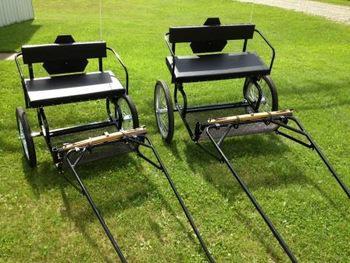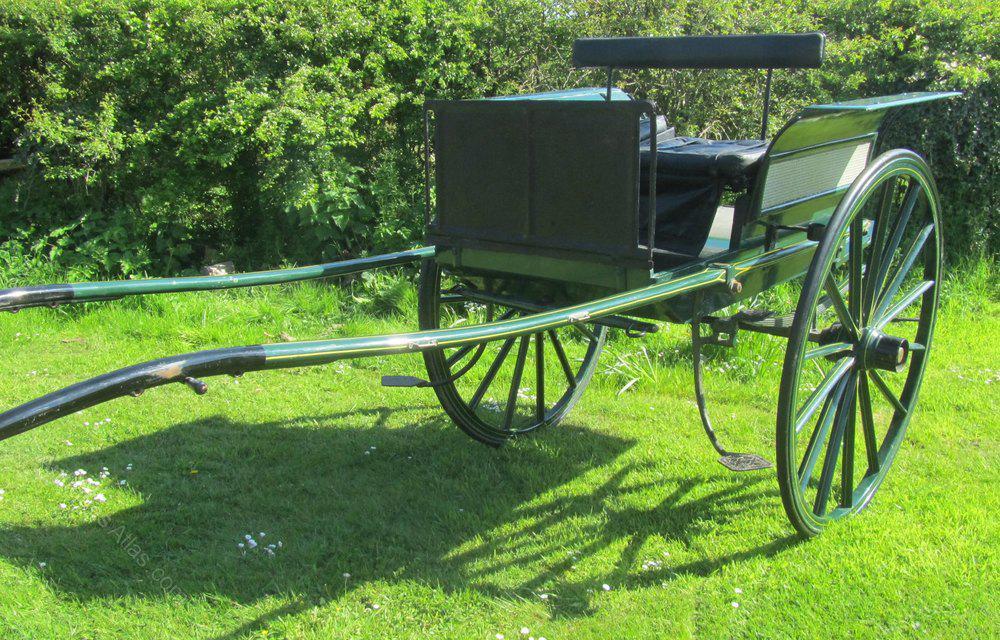The first image is the image on the left, the second image is the image on the right. Assess this claim about the two images: "One of the carriages is red and black.". Correct or not? Answer yes or no. No. 